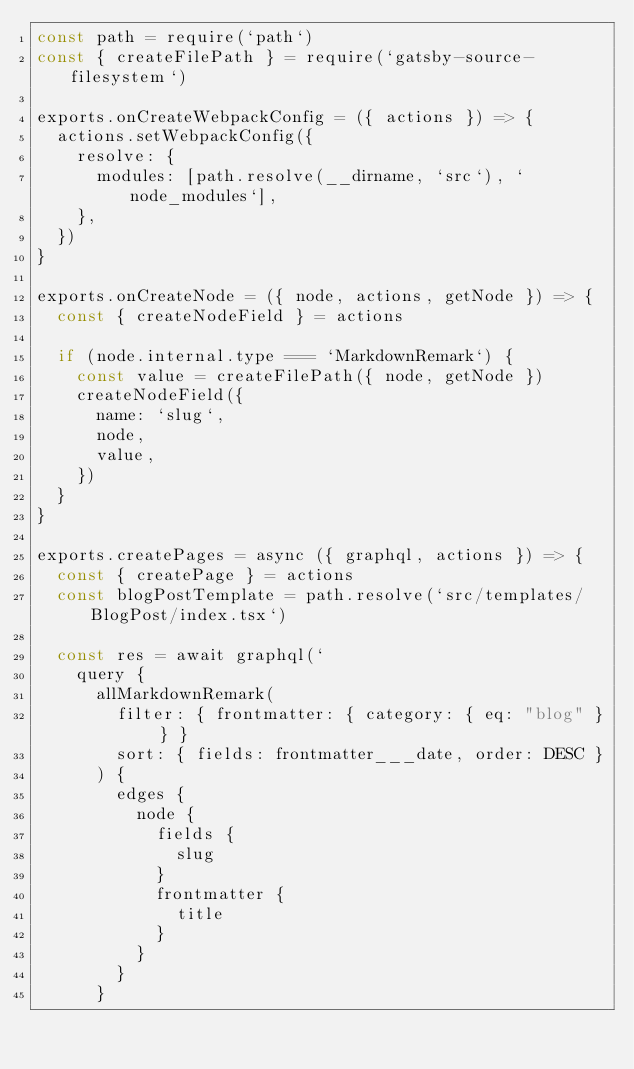<code> <loc_0><loc_0><loc_500><loc_500><_JavaScript_>const path = require(`path`)
const { createFilePath } = require(`gatsby-source-filesystem`)

exports.onCreateWebpackConfig = ({ actions }) => {
  actions.setWebpackConfig({
    resolve: {
      modules: [path.resolve(__dirname, `src`), `node_modules`],
    },
  })
}

exports.onCreateNode = ({ node, actions, getNode }) => {
  const { createNodeField } = actions

  if (node.internal.type === `MarkdownRemark`) {
    const value = createFilePath({ node, getNode })
    createNodeField({
      name: `slug`,
      node,
      value,
    })
  }
}

exports.createPages = async ({ graphql, actions }) => {
  const { createPage } = actions
  const blogPostTemplate = path.resolve(`src/templates/BlogPost/index.tsx`)

  const res = await graphql(`
    query {
      allMarkdownRemark(
        filter: { frontmatter: { category: { eq: "blog" } } }
        sort: { fields: frontmatter___date, order: DESC }
      ) {
        edges {
          node {
            fields {
              slug
            }
            frontmatter {
              title
            }
          }
        }
      }</code> 